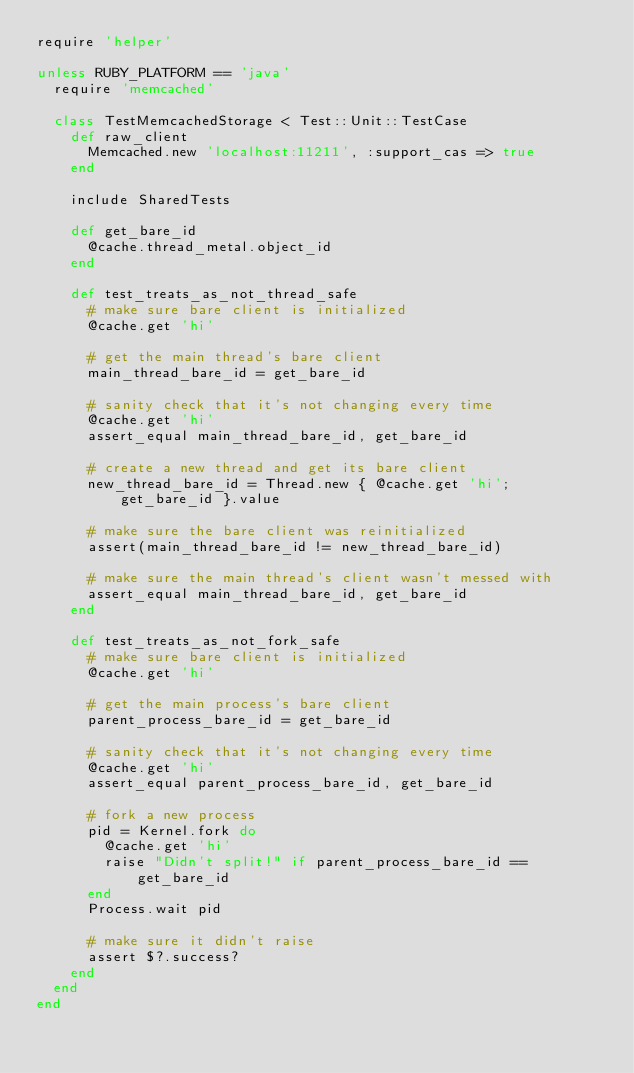<code> <loc_0><loc_0><loc_500><loc_500><_Ruby_>require 'helper'

unless RUBY_PLATFORM == 'java'
  require 'memcached'

  class TestMemcachedStorage < Test::Unit::TestCase
    def raw_client
      Memcached.new 'localhost:11211', :support_cas => true
    end
      
    include SharedTests
    
    def get_bare_id
      @cache.thread_metal.object_id
    end
    
    def test_treats_as_not_thread_safe
      # make sure bare client is initialized
      @cache.get 'hi'
      
      # get the main thread's bare client
      main_thread_bare_id = get_bare_id
      
      # sanity check that it's not changing every time
      @cache.get 'hi'
      assert_equal main_thread_bare_id, get_bare_id
      
      # create a new thread and get its bare client
      new_thread_bare_id = Thread.new { @cache.get 'hi'; get_bare_id }.value
      
      # make sure the bare client was reinitialized
      assert(main_thread_bare_id != new_thread_bare_id)

      # make sure the main thread's client wasn't messed with
      assert_equal main_thread_bare_id, get_bare_id
    end
    
    def test_treats_as_not_fork_safe
      # make sure bare client is initialized
      @cache.get 'hi'
      
      # get the main process's bare client
      parent_process_bare_id = get_bare_id
      
      # sanity check that it's not changing every time
      @cache.get 'hi'
      assert_equal parent_process_bare_id, get_bare_id
      
      # fork a new process
      pid = Kernel.fork do
        @cache.get 'hi'
        raise "Didn't split!" if parent_process_bare_id == get_bare_id
      end
      Process.wait pid
      
      # make sure it didn't raise
      assert $?.success?
    end
  end
end
</code> 